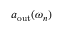<formula> <loc_0><loc_0><loc_500><loc_500>a _ { o u t } ( \omega _ { n } )</formula> 